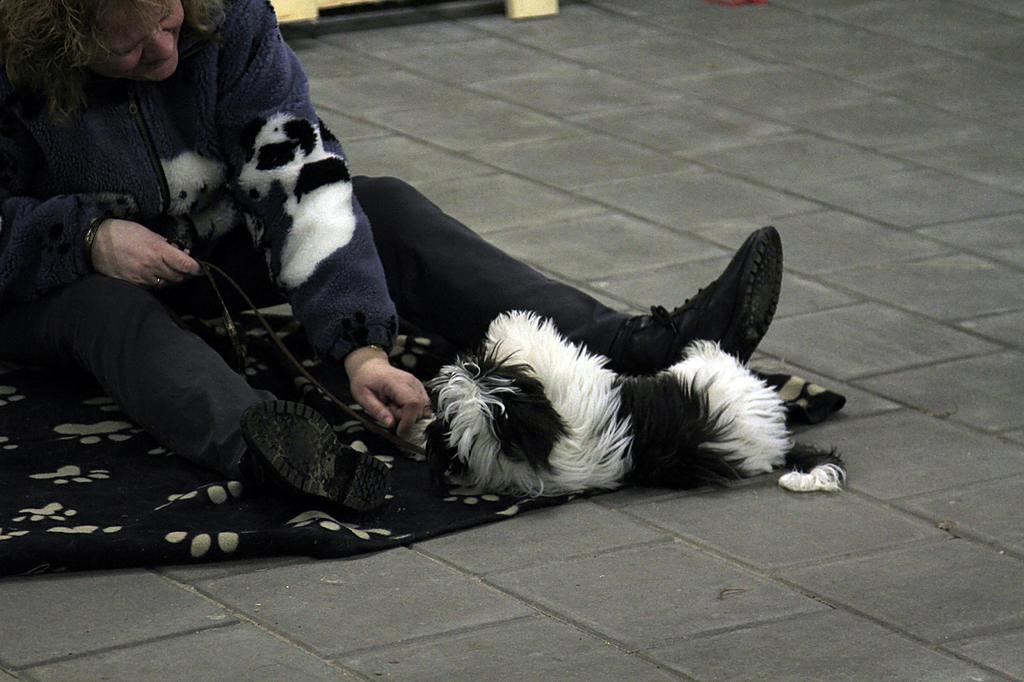In one or two sentences, can you explain what this image depicts? In this image i can see a person sitting, wearing a jacket, shoes and jeans. I can see a animal lying on the floor. 